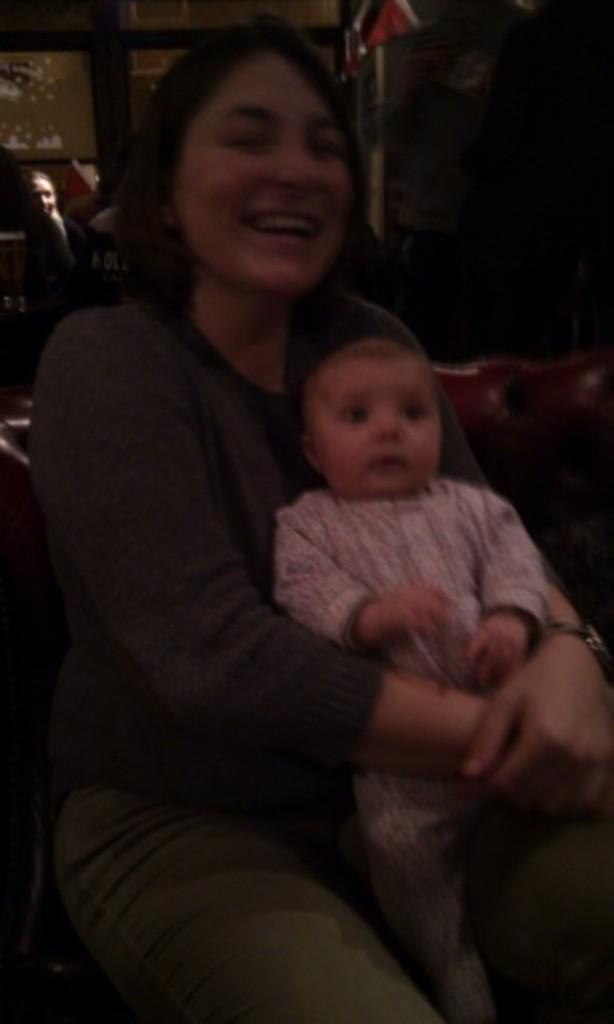What is the woman in the image doing? The woman is sitting and smiling in the image. What is the woman holding in the image? The woman is holding a baby. Can you describe the person at the back of the image? There is a person at the back of the image, but no specific details are provided. What can be seen in the reflection of the mirror in the image? There is a reflection of a tree on a mirror in the image. What type of music can be heard playing in the background of the image? There is no indication of music or any sound in the image, so it cannot be determined from the picture. 